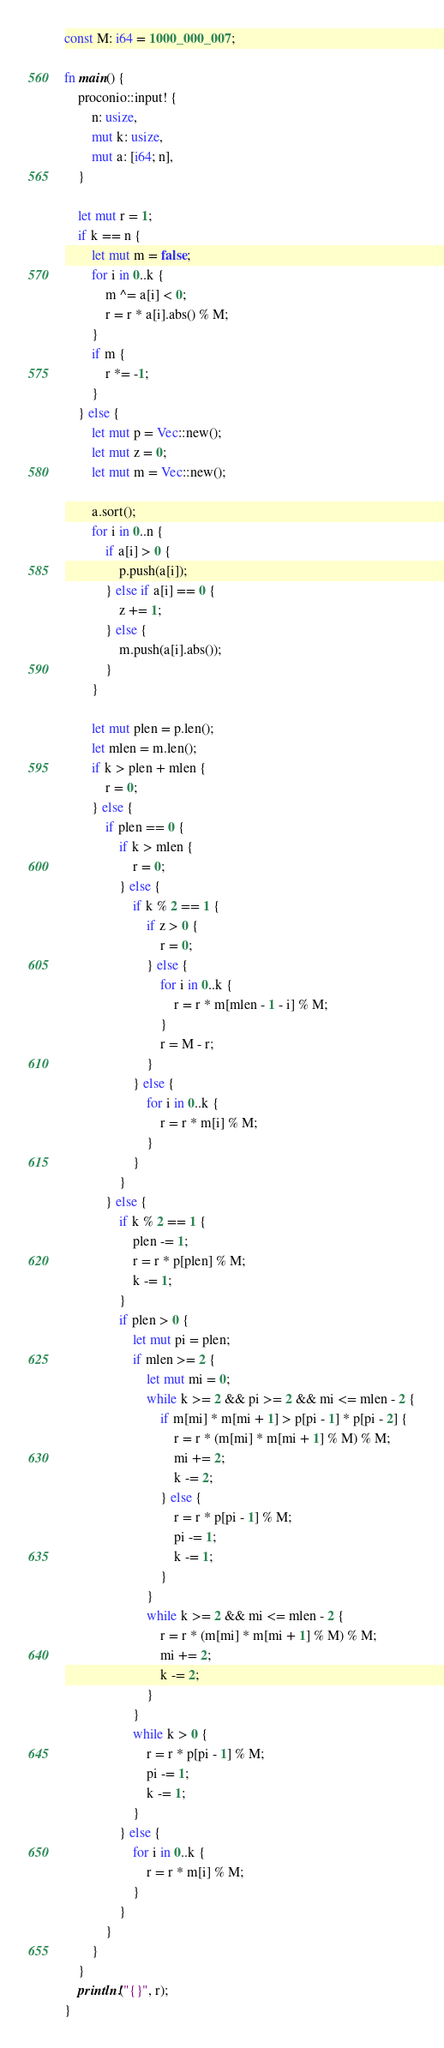Convert code to text. <code><loc_0><loc_0><loc_500><loc_500><_Rust_>const M: i64 = 1000_000_007;

fn main() {
    proconio::input! {
        n: usize,
        mut k: usize,
        mut a: [i64; n],
    }

    let mut r = 1;
    if k == n {
        let mut m = false;
        for i in 0..k {
            m ^= a[i] < 0;
            r = r * a[i].abs() % M;
        }
        if m {
            r *= -1;
        }
    } else {
        let mut p = Vec::new();
        let mut z = 0;
        let mut m = Vec::new();

        a.sort();
        for i in 0..n {
            if a[i] > 0 {
                p.push(a[i]);
            } else if a[i] == 0 {
                z += 1;
            } else {
                m.push(a[i].abs());
            }
        }

        let mut plen = p.len();
        let mlen = m.len();
        if k > plen + mlen {
            r = 0;
        } else {
            if plen == 0 {
                if k > mlen {
                    r = 0;
                } else {
                    if k % 2 == 1 {
                        if z > 0 {
                            r = 0;
                        } else {
                            for i in 0..k {
                                r = r * m[mlen - 1 - i] % M;
                            }
                            r = M - r;
                        }
                    } else {
                        for i in 0..k {
                            r = r * m[i] % M;
                        }
                    }
                }
            } else {
                if k % 2 == 1 {
                    plen -= 1;
                    r = r * p[plen] % M;
                    k -= 1;
                }
                if plen > 0 {
                    let mut pi = plen;
                    if mlen >= 2 {
                        let mut mi = 0;
                        while k >= 2 && pi >= 2 && mi <= mlen - 2 {
                            if m[mi] * m[mi + 1] > p[pi - 1] * p[pi - 2] {
                                r = r * (m[mi] * m[mi + 1] % M) % M;
                                mi += 2;
                                k -= 2;
                            } else {
                                r = r * p[pi - 1] % M;
                                pi -= 1;
                                k -= 1;
                            }
                        }
                        while k >= 2 && mi <= mlen - 2 {
                            r = r * (m[mi] * m[mi + 1] % M) % M;
                            mi += 2;
                            k -= 2;
                        }
                    }
                    while k > 0 {
                        r = r * p[pi - 1] % M;
                        pi -= 1;
                        k -= 1;
                    }
                } else {
                    for i in 0..k {
                        r = r * m[i] % M;
                    }
                }
            }
        }
    }
    println!("{}", r);
}
</code> 